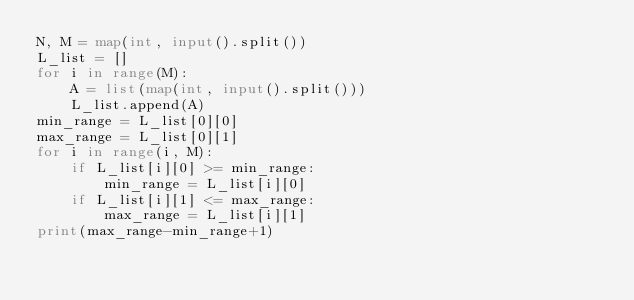Convert code to text. <code><loc_0><loc_0><loc_500><loc_500><_Python_>N, M = map(int, input().split())
L_list = []
for i in range(M):
    A = list(map(int, input().split()))
    L_list.append(A)
min_range = L_list[0][0]
max_range = L_list[0][1]
for i in range(i, M):
    if L_list[i][0] >= min_range:
        min_range = L_list[i][0]
    if L_list[i][1] <= max_range:
        max_range = L_list[i][1]
print(max_range-min_range+1)</code> 